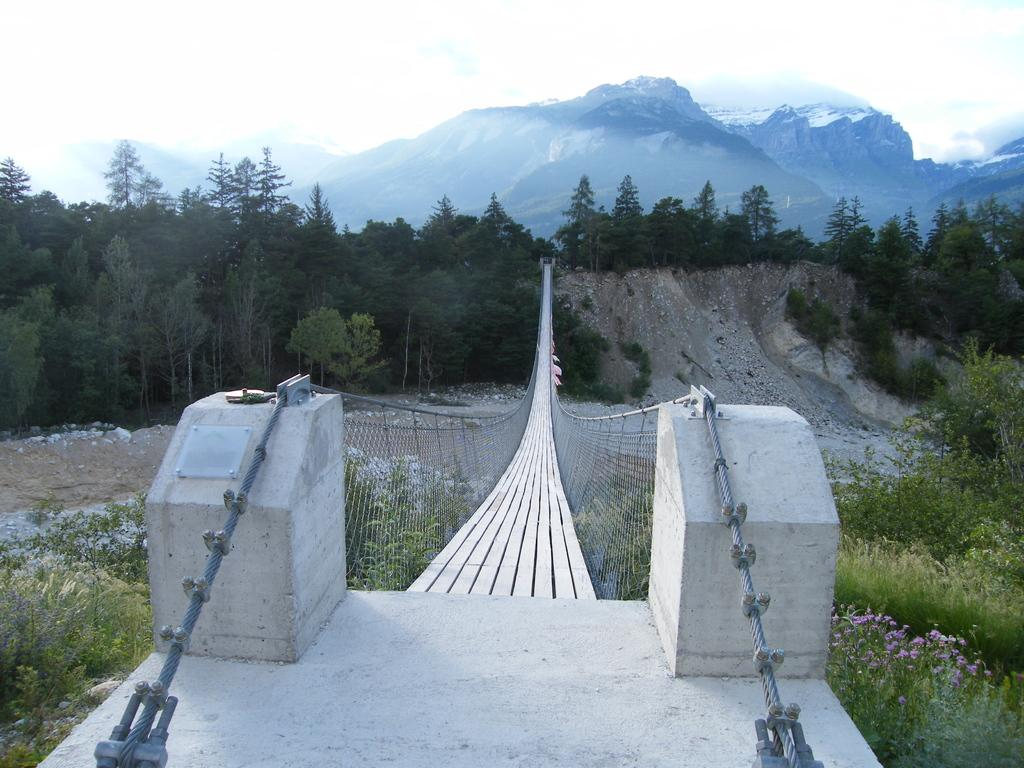What type of natural landscape is depicted in the image? The image features many mountains and trees, indicating a mountainous landscape. What other types of vegetation can be seen in the image? There are plants in the image, in addition to the trees. What man-made structure is present in the image? There is a bridge in the image. What can be seen above the landscape in the image? There is a sky visible in the image. What type of wool is being used to make the clouds in the image? There is no wool present in the image; the clouds are natural formations in the sky. 